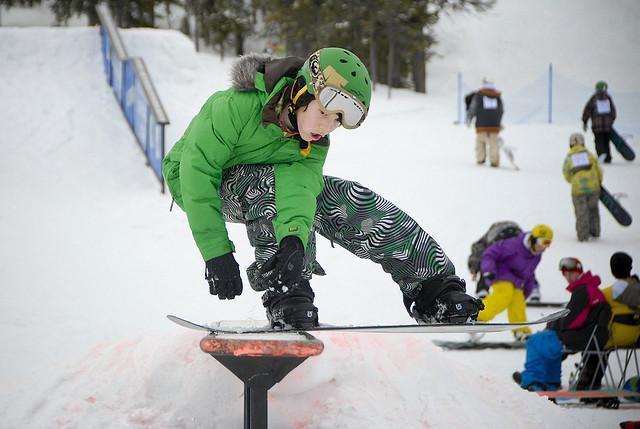How many people are visible?
Give a very brief answer. 6. How many snowboards are in the picture?
Give a very brief answer. 1. How many red frisbees can you see?
Give a very brief answer. 0. 